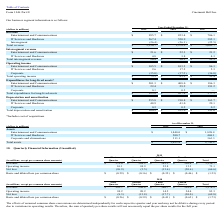According to Cincinnati Bell's financial document, What is the company's total assets as at December 31, 2019? According to the financial document, $2,653.8 (in millions). The relevant text states: "Total assets $ 2,653.8 $ 2,730.2..." Also, What is the company's total assets as at December 31, 2018? According to the financial document, $2,730.2 (in millions). The relevant text states: "Total assets $ 2,653.8 $ 2,730.2..." Also, can you calculate: What is the sum of company's total assets between 2018 to 2019? Based on the calculation: $2,653.8  +$2,730.2, the result is 5384 (in millions). This is based on the information: "Total assets $ 2,653.8 $ 2,730.2 Total assets $ 2,653.8 $ 2,730.2..." The key data points involved are: 2,653.8, 2,730.2. Also, What is the company's 2019 assets under IT services and hardware? According to the financial document, 500.7 (in millions). The relevant text states: "IT Services and Hardware 500.7 468.1..." Additionally, Which asset classification makes up the biggest proportion of the company's assets as at December 31, 2019? Entertainment and Communication. The document states: "Entertainment and Communications $ 995.7 $ 853.4 $ 706.1..." Also, can you calculate: What is the change in the value of the company's total assets between 2018 and 2019? Based on the calculation: $2,653.8 - $2,730.2 , the result is -76.4 (in millions). This is based on the information: "Total assets $ 2,653.8 $ 2,730.2 Total assets $ 2,653.8 $ 2,730.2..." The key data points involved are: 2,653.8, 2,730.2. Also, Why did Corporate assets decrease? Based on the financial document, the answer is Corporate assets decreased $50.2 million primarily due to decreased receivables.. 